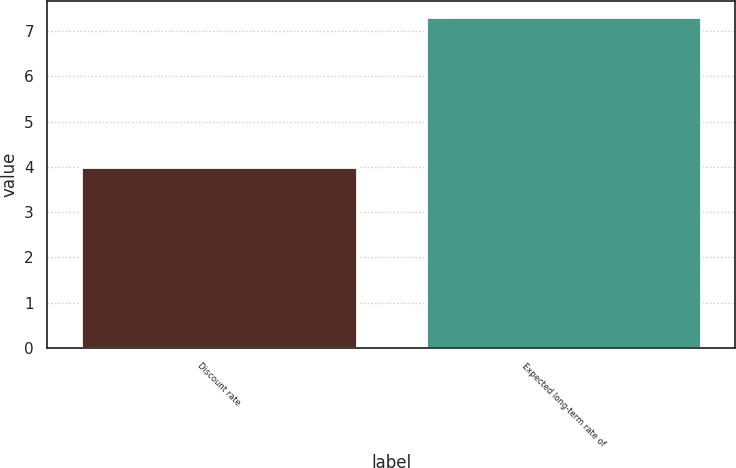Convert chart. <chart><loc_0><loc_0><loc_500><loc_500><bar_chart><fcel>Discount rate<fcel>Expected long-term rate of<nl><fcel>4<fcel>7.3<nl></chart> 